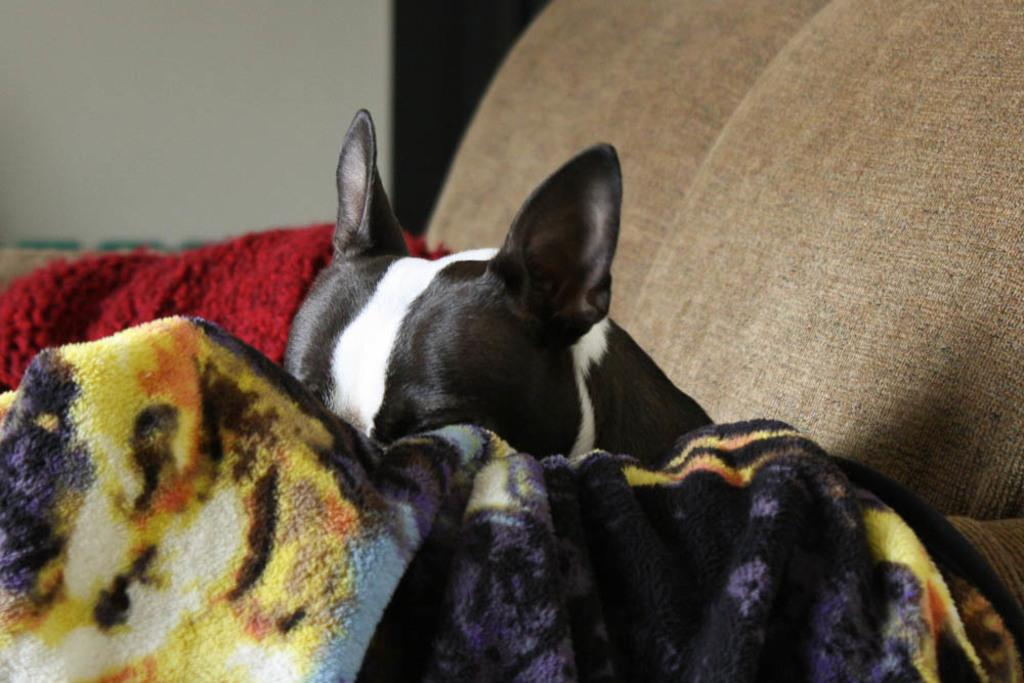What type of animal is in the image? There is a dog in the image. What colors can be seen on the dog? The dog is black and white in color. Where is the dog located in the image? The dog is on a sofa. What else can be seen in the background of the image? There are other objects in the background of the image. How many cakes are on the plough in the image? There is no plough or cakes present in the image; it features a dog on a sofa. What type of bird can be seen flying in the image? There is no bird visible in the image. 